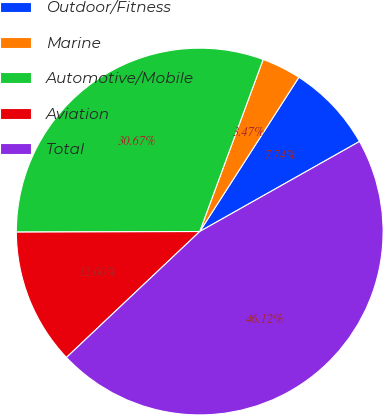Convert chart. <chart><loc_0><loc_0><loc_500><loc_500><pie_chart><fcel>Outdoor/Fitness<fcel>Marine<fcel>Automotive/Mobile<fcel>Aviation<fcel>Total<nl><fcel>7.74%<fcel>3.47%<fcel>30.67%<fcel>12.0%<fcel>46.12%<nl></chart> 